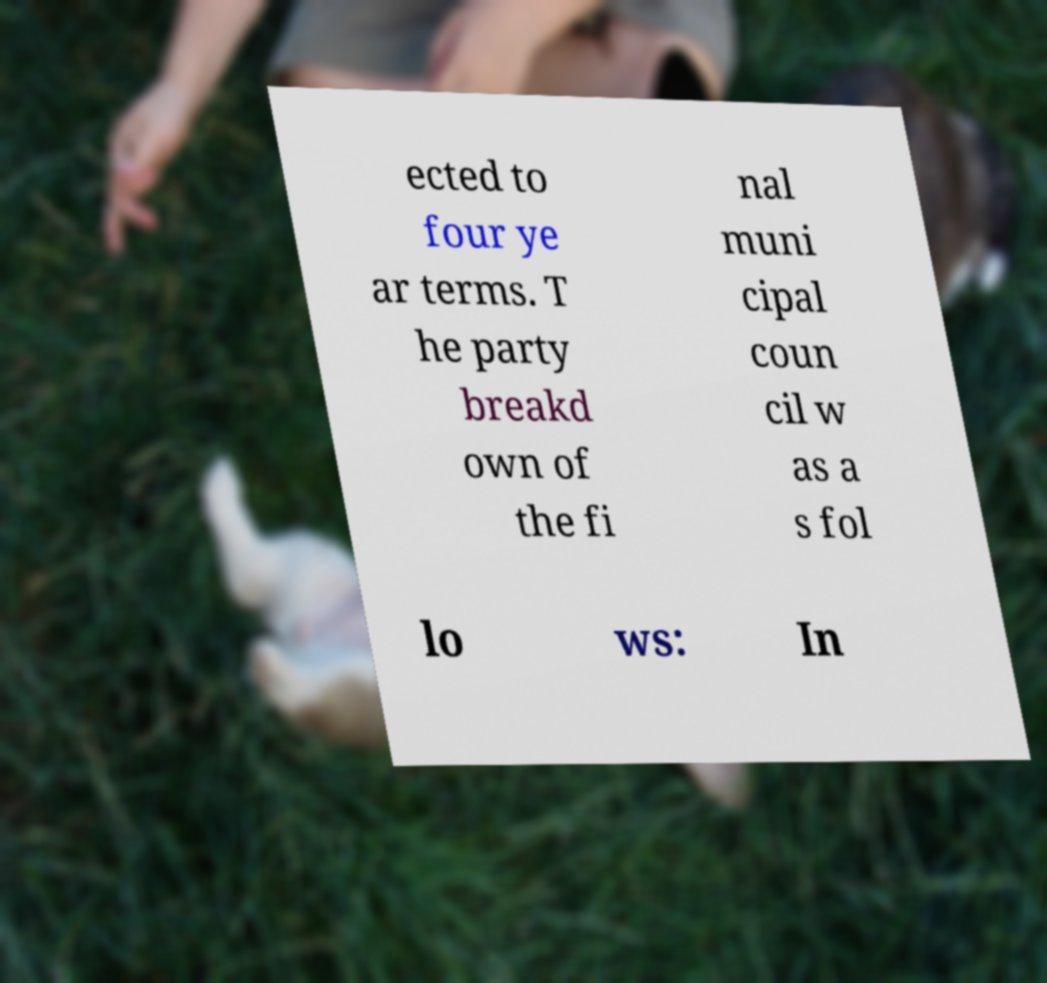I need the written content from this picture converted into text. Can you do that? ected to four ye ar terms. T he party breakd own of the fi nal muni cipal coun cil w as a s fol lo ws: In 